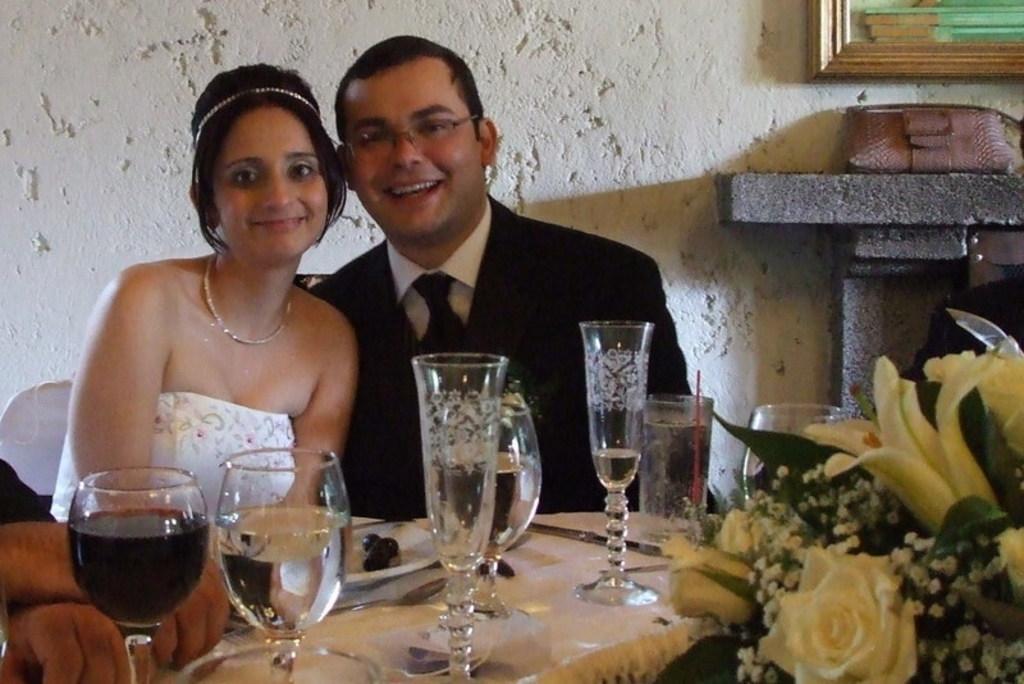In one or two sentences, can you explain what this image depicts? In this image I can see two people sitting and smiling. I can see glasses,spoon,plates on the table. In front I can see few white flowers and leaves. Back the frame is attached to the white wall. 